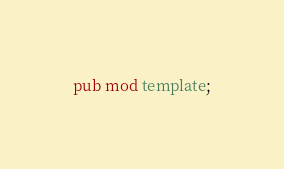<code> <loc_0><loc_0><loc_500><loc_500><_Rust_>pub mod template;</code> 